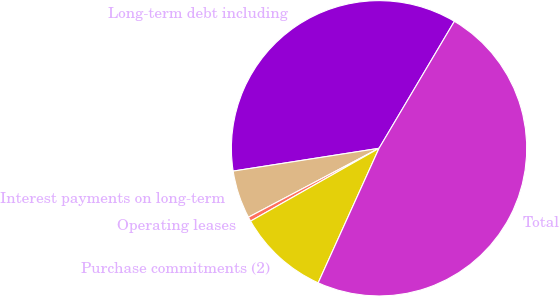Convert chart to OTSL. <chart><loc_0><loc_0><loc_500><loc_500><pie_chart><fcel>Long-term debt including<fcel>Interest payments on long-term<fcel>Operating leases<fcel>Purchase commitments (2)<fcel>Total<nl><fcel>35.99%<fcel>5.26%<fcel>0.48%<fcel>10.03%<fcel>48.24%<nl></chart> 